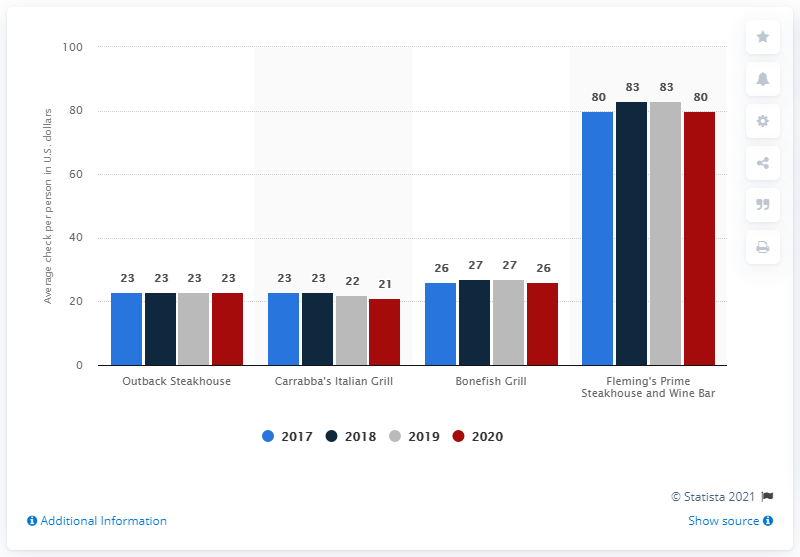Identify some key points in this picture. Fleming's Prime Steakhouse and Wine Bar has consistently had the highest price among all restaurants for all years. Outback Steakhouse has maintained the same brand value for all years. 